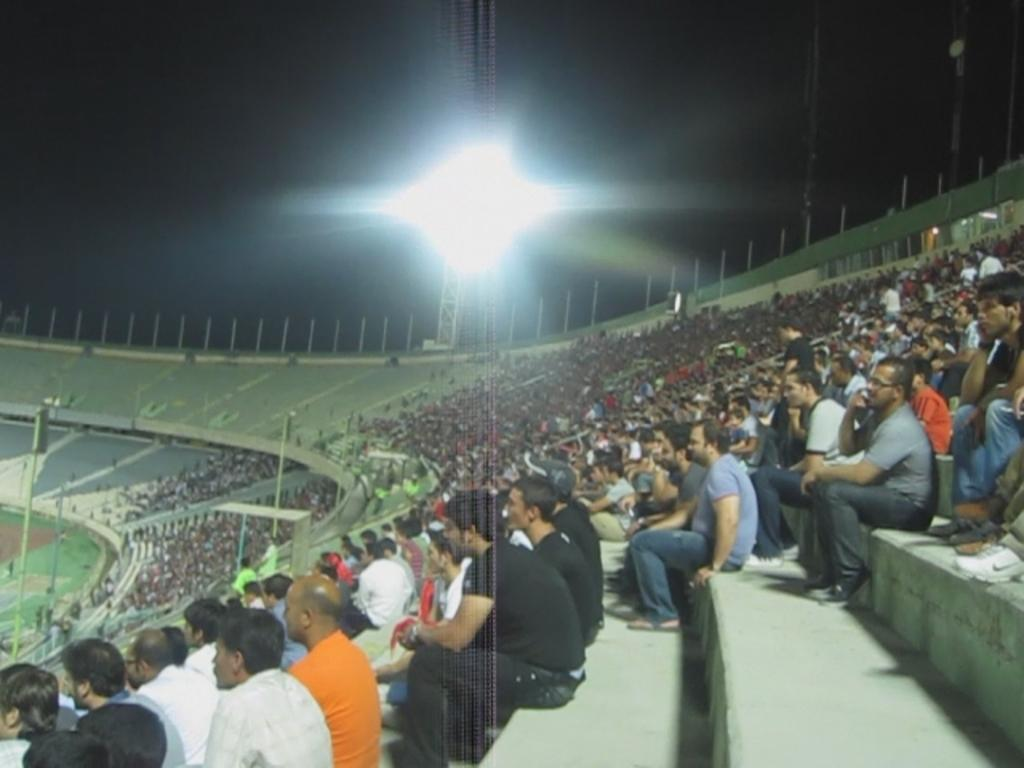Where was the image taken? The image was taken in a stadium. What can be seen in the foreground of the image? There are people and a staircase in the foreground of the image. What is visible in the background of the image? There are flood lights in the background of the image. How would you describe the lighting conditions in the image? The sky is dark in the image. What type of chair is being used by the people in the image to generate profit? There is no mention of chairs or profit generation in the image. The image shows people in a stadium with flood lights in the background, and the sky is dark. 